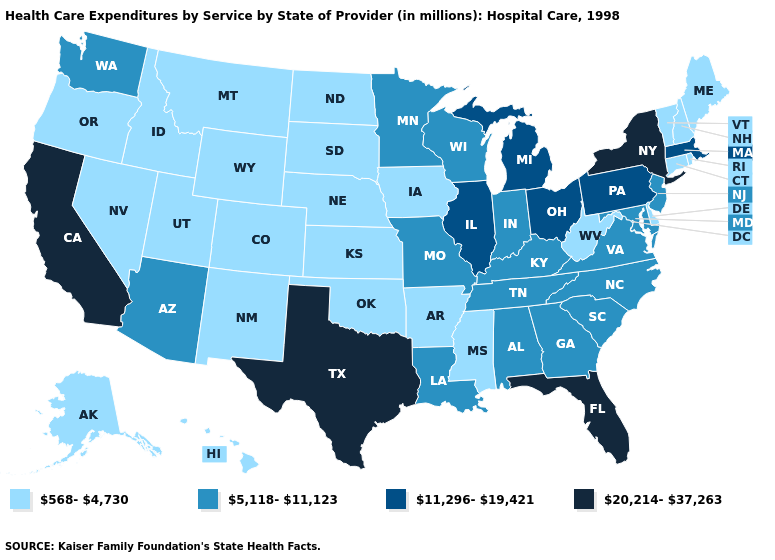What is the value of Florida?
Keep it brief. 20,214-37,263. Name the states that have a value in the range 20,214-37,263?
Answer briefly. California, Florida, New York, Texas. Name the states that have a value in the range 11,296-19,421?
Short answer required. Illinois, Massachusetts, Michigan, Ohio, Pennsylvania. What is the value of Washington?
Answer briefly. 5,118-11,123. Name the states that have a value in the range 568-4,730?
Be succinct. Alaska, Arkansas, Colorado, Connecticut, Delaware, Hawaii, Idaho, Iowa, Kansas, Maine, Mississippi, Montana, Nebraska, Nevada, New Hampshire, New Mexico, North Dakota, Oklahoma, Oregon, Rhode Island, South Dakota, Utah, Vermont, West Virginia, Wyoming. Does Virginia have the same value as Colorado?
Write a very short answer. No. What is the value of South Dakota?
Quick response, please. 568-4,730. How many symbols are there in the legend?
Be succinct. 4. Which states hav the highest value in the South?
Quick response, please. Florida, Texas. Name the states that have a value in the range 20,214-37,263?
Give a very brief answer. California, Florida, New York, Texas. Name the states that have a value in the range 11,296-19,421?
Write a very short answer. Illinois, Massachusetts, Michigan, Ohio, Pennsylvania. Among the states that border Michigan , does Indiana have the highest value?
Quick response, please. No. Which states have the highest value in the USA?
Be succinct. California, Florida, New York, Texas. Does the first symbol in the legend represent the smallest category?
Write a very short answer. Yes. What is the value of Vermont?
Give a very brief answer. 568-4,730. 